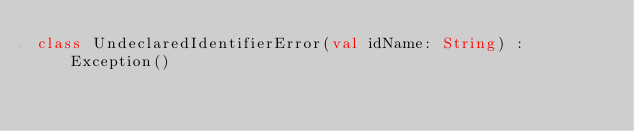<code> <loc_0><loc_0><loc_500><loc_500><_Kotlin_>class UndeclaredIdentifierError(val idName: String) : Exception()
</code> 